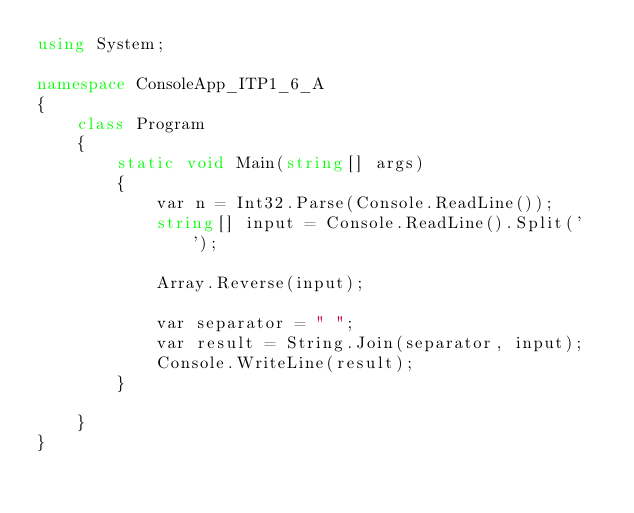Convert code to text. <code><loc_0><loc_0><loc_500><loc_500><_C#_>using System;

namespace ConsoleApp_ITP1_6_A
{
    class Program
    {
        static void Main(string[] args)
        {
            var n = Int32.Parse(Console.ReadLine());
            string[] input = Console.ReadLine().Split(' ');

            Array.Reverse(input);

            var separator = " ";
            var result = String.Join(separator, input);
            Console.WriteLine(result);
        }

    }
}
</code> 